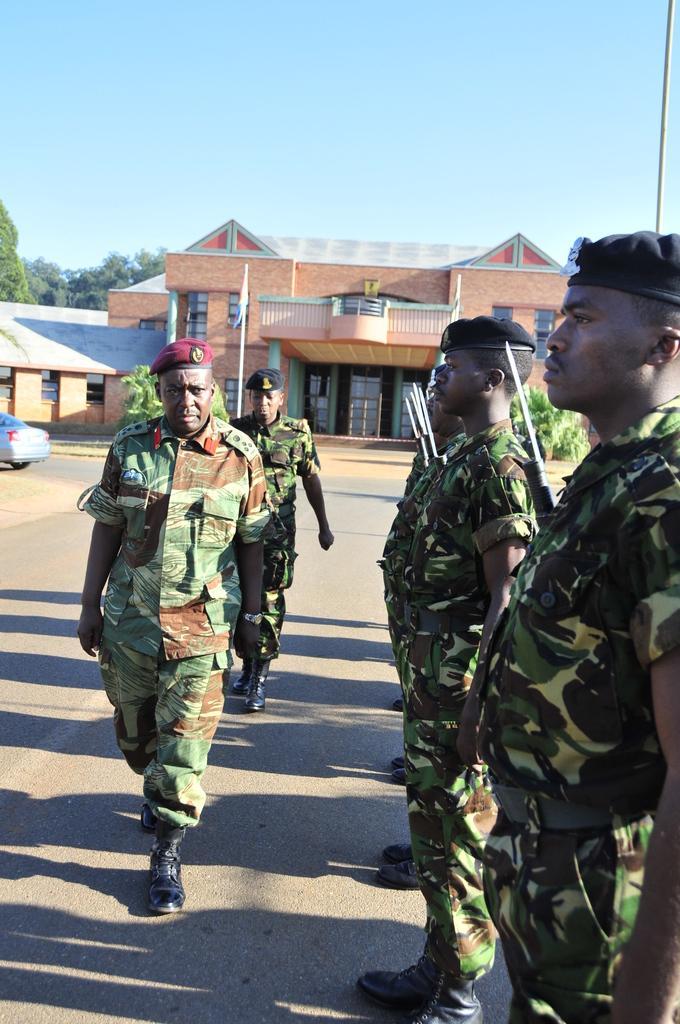Can you describe this image briefly? In the middle of the image on the road there is a man with green and brown color uniform and also there is a maroon color cap on his head is walking on the road. Behind him there is a man with green uniform and a black cap on his head. To the right side of the image there are few men with green uniform and black cap on their heads is standing on the roads. In the background there is a house building with roofs, walls,windows and pillars. And to the left side of the image there is a car on the road. To the top of the image there is a blue sky. 